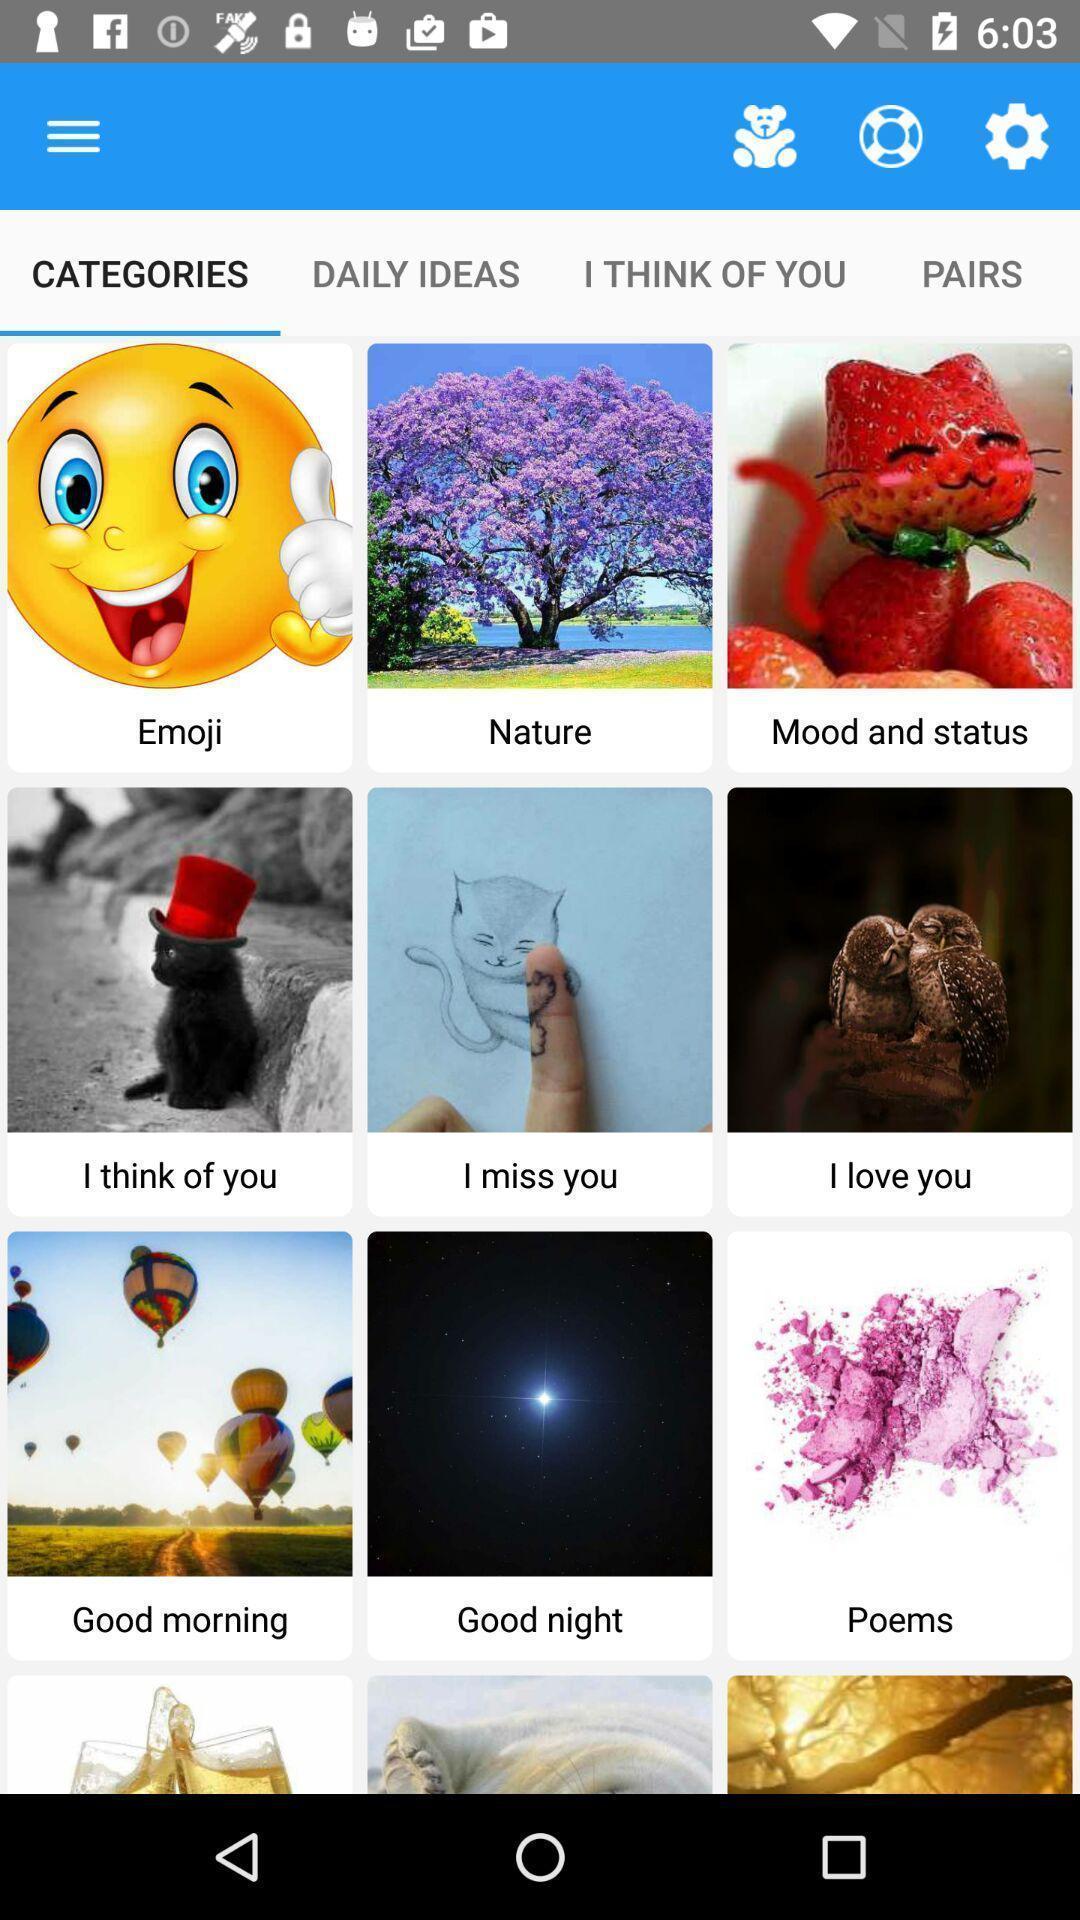Provide a description of this screenshot. Screen displaying categories page of emojis and stickers app. 